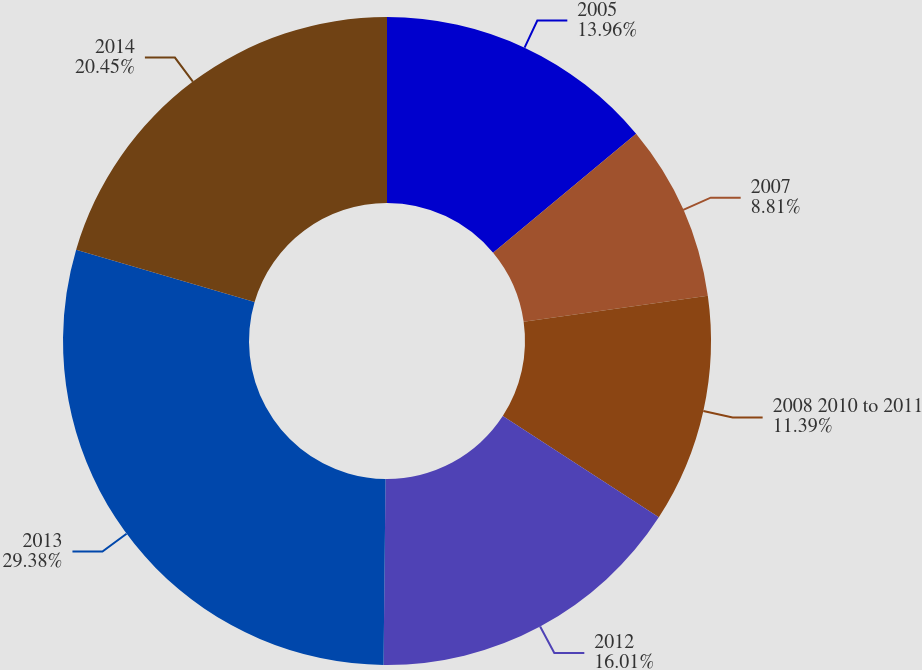<chart> <loc_0><loc_0><loc_500><loc_500><pie_chart><fcel>2005<fcel>2007<fcel>2008 2010 to 2011<fcel>2012<fcel>2013<fcel>2014<nl><fcel>13.96%<fcel>8.81%<fcel>11.39%<fcel>16.01%<fcel>29.38%<fcel>20.45%<nl></chart> 